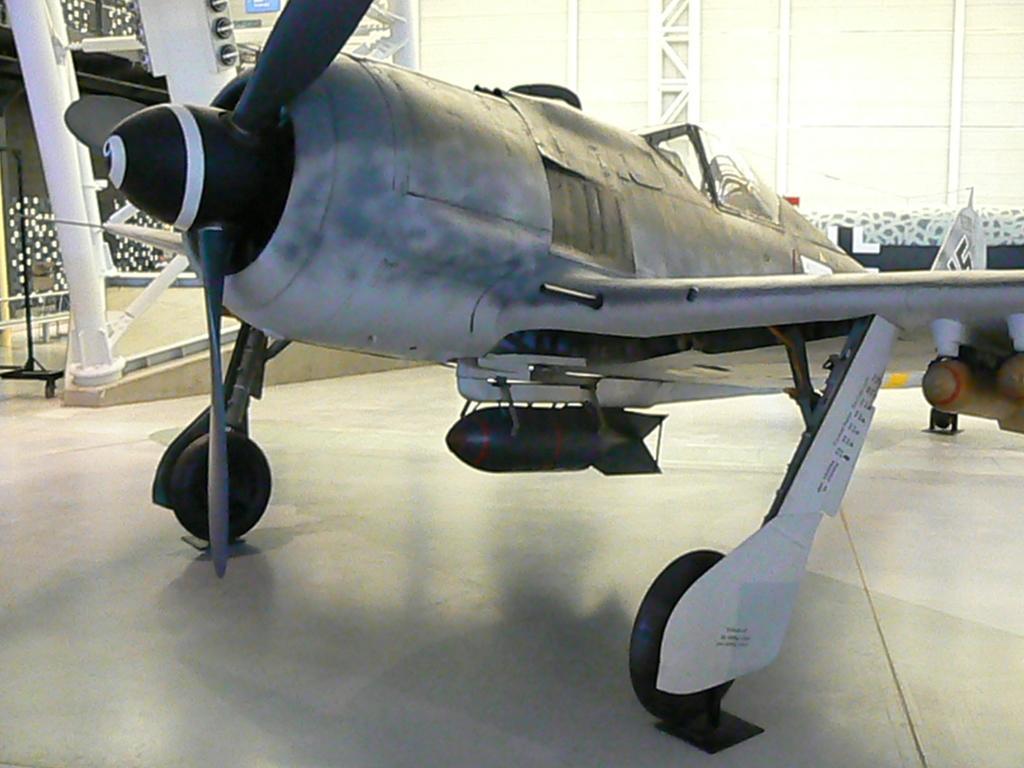In one or two sentences, can you explain what this image depicts? In this image there is an aircraft on the floor. In the background there is a wall and some metal structures and there are lights. 